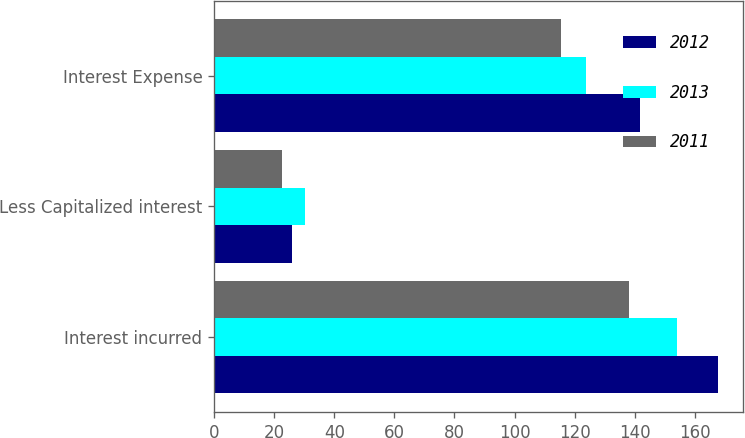<chart> <loc_0><loc_0><loc_500><loc_500><stacked_bar_chart><ecel><fcel>Interest incurred<fcel>Less Capitalized interest<fcel>Interest Expense<nl><fcel>2012<fcel>167.6<fcel>25.8<fcel>141.8<nl><fcel>2013<fcel>153.9<fcel>30.2<fcel>123.7<nl><fcel>2011<fcel>138.2<fcel>22.7<fcel>115.5<nl></chart> 